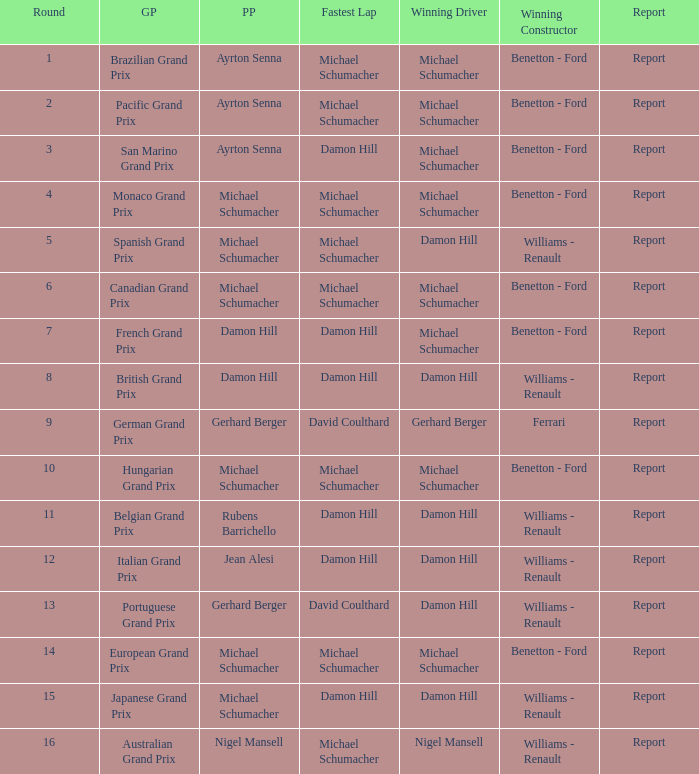Name the lowest round for when pole position and winning driver is michael schumacher 4.0. 